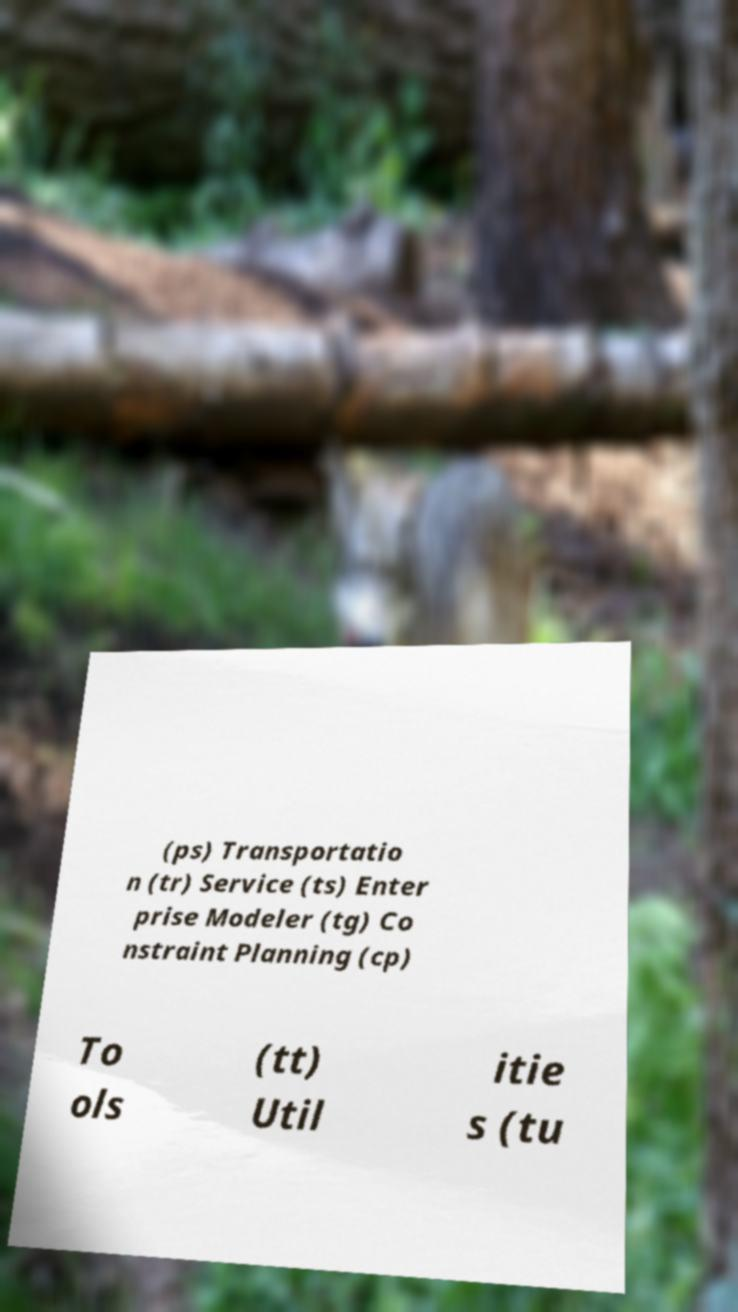Could you assist in decoding the text presented in this image and type it out clearly? (ps) Transportatio n (tr) Service (ts) Enter prise Modeler (tg) Co nstraint Planning (cp) To ols (tt) Util itie s (tu 